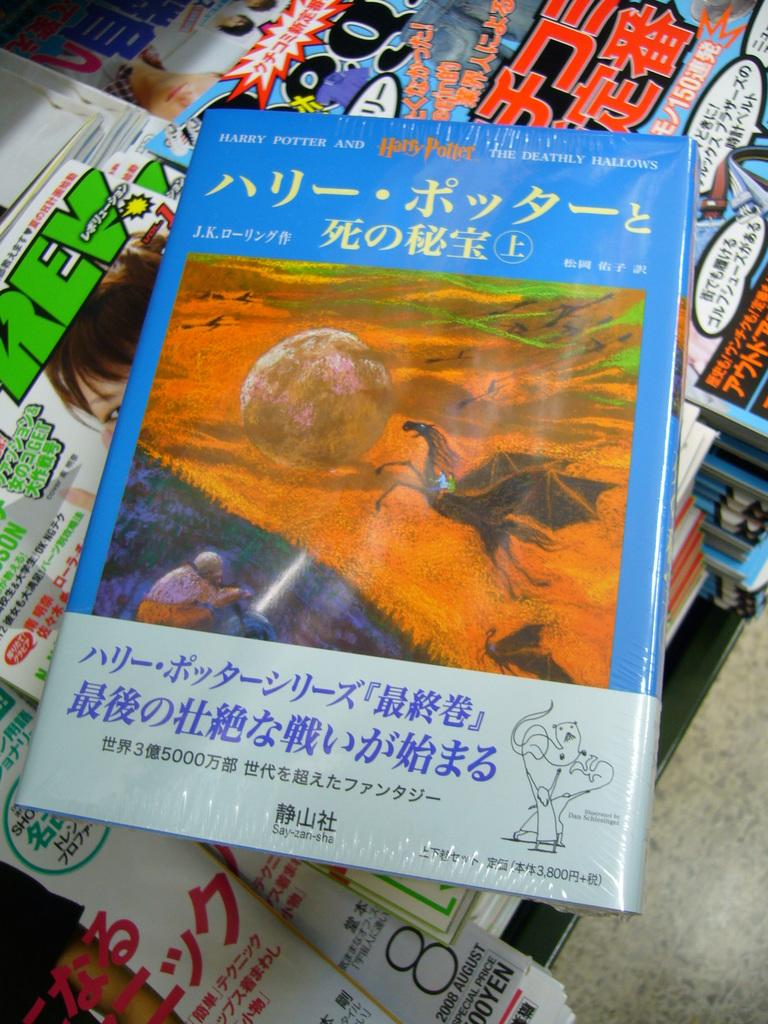<image>
Summarize the visual content of the image. A copy of Harry Potter in another language sits on a pile of magazines. 